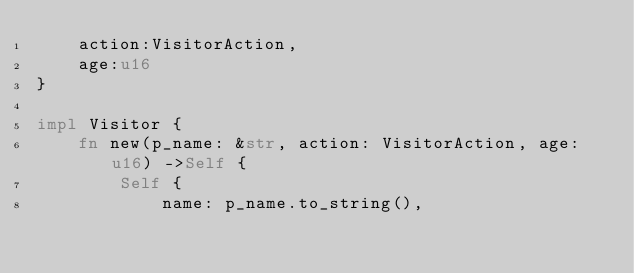Convert code to text. <code><loc_0><loc_0><loc_500><loc_500><_Rust_>    action:VisitorAction,
    age:u16
}

impl Visitor {
    fn new(p_name: &str, action: VisitorAction, age: u16) ->Self {
        Self {
            name: p_name.to_string(),</code> 